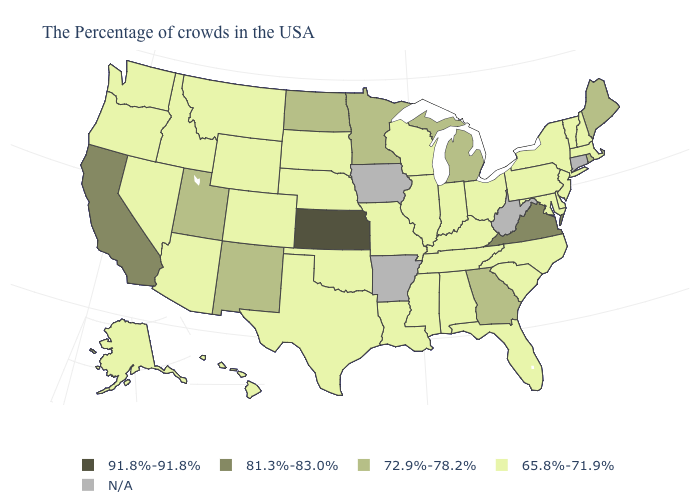Which states have the lowest value in the USA?
Write a very short answer. Massachusetts, New Hampshire, Vermont, New York, New Jersey, Delaware, Maryland, Pennsylvania, North Carolina, South Carolina, Ohio, Florida, Kentucky, Indiana, Alabama, Tennessee, Wisconsin, Illinois, Mississippi, Louisiana, Missouri, Nebraska, Oklahoma, Texas, South Dakota, Wyoming, Colorado, Montana, Arizona, Idaho, Nevada, Washington, Oregon, Alaska, Hawaii. What is the value of Oregon?
Write a very short answer. 65.8%-71.9%. Name the states that have a value in the range 81.3%-83.0%?
Answer briefly. Virginia, California. Name the states that have a value in the range 81.3%-83.0%?
Answer briefly. Virginia, California. What is the value of Virginia?
Write a very short answer. 81.3%-83.0%. Name the states that have a value in the range 91.8%-91.8%?
Write a very short answer. Kansas. Name the states that have a value in the range 91.8%-91.8%?
Quick response, please. Kansas. How many symbols are there in the legend?
Answer briefly. 5. Does Kansas have the highest value in the USA?
Quick response, please. Yes. Name the states that have a value in the range 81.3%-83.0%?
Quick response, please. Virginia, California. Name the states that have a value in the range 91.8%-91.8%?
Short answer required. Kansas. Does the first symbol in the legend represent the smallest category?
Quick response, please. No. How many symbols are there in the legend?
Answer briefly. 5. Name the states that have a value in the range 65.8%-71.9%?
Give a very brief answer. Massachusetts, New Hampshire, Vermont, New York, New Jersey, Delaware, Maryland, Pennsylvania, North Carolina, South Carolina, Ohio, Florida, Kentucky, Indiana, Alabama, Tennessee, Wisconsin, Illinois, Mississippi, Louisiana, Missouri, Nebraska, Oklahoma, Texas, South Dakota, Wyoming, Colorado, Montana, Arizona, Idaho, Nevada, Washington, Oregon, Alaska, Hawaii. 